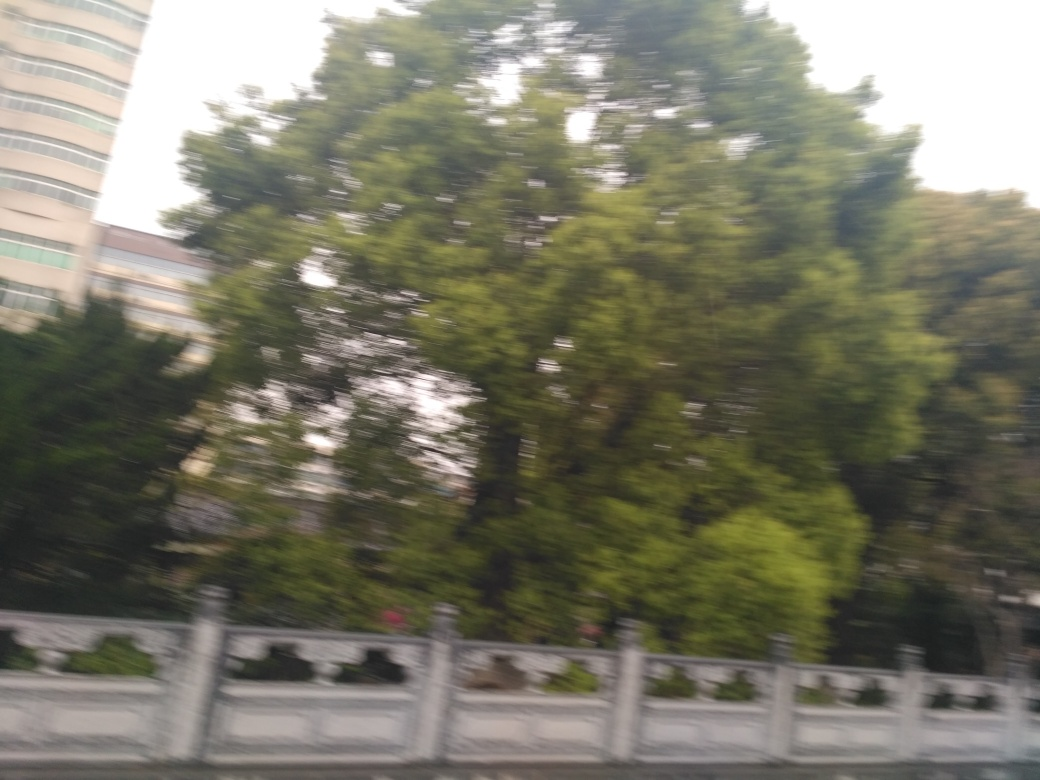Is it identifiable as a roadside guardrail and some trees? Yes, the image clearly shows a roadside guardrail alongside which there are several trees. The trees appear to provide a natural barrier adjacent to the road, enhancing the safety and aesthetic of the area. Even though the photograph is a bit blurry, it seems to have been taken from a moving vehicle, giving a sense of motion and a glimpse into the dynamic nature of travel. 